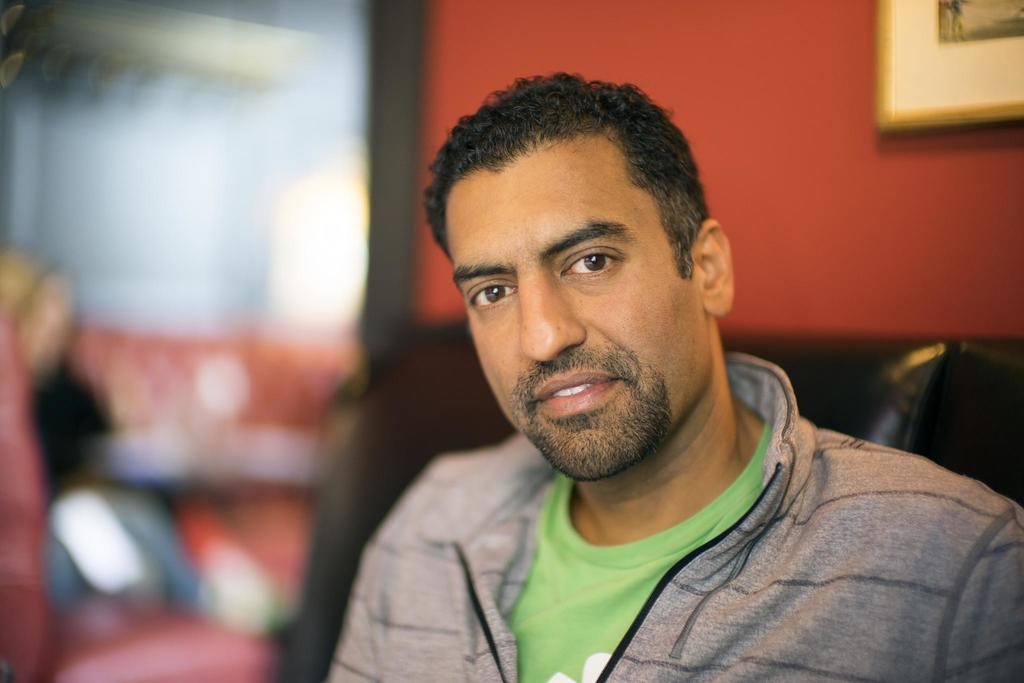Who is present in the image? There is a man in the image. What is the man wearing? The man is wearing a jacket. What piece of furniture can be seen in the image? There is a sofa in the image. Can you describe the background of the image? The background of the image is blurry. What is visible on the wall in the background? There is a frame on a wall in the background. What degree does the man have, as seen in the image? There is no indication of the man's degree in the image. Can you see any snakes in the image? There are no snakes present in the image. 